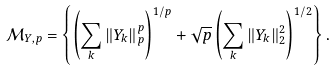<formula> <loc_0><loc_0><loc_500><loc_500>\mathcal { M } _ { Y , p } = \left \{ \left ( \sum _ { k } \| Y _ { k } \| _ { p } ^ { p } \right ) ^ { 1 / p } + \sqrt { p } \left ( \sum _ { k } \| Y _ { k } \| _ { 2 } ^ { 2 } \right ) ^ { 1 / 2 } \right \} .</formula> 